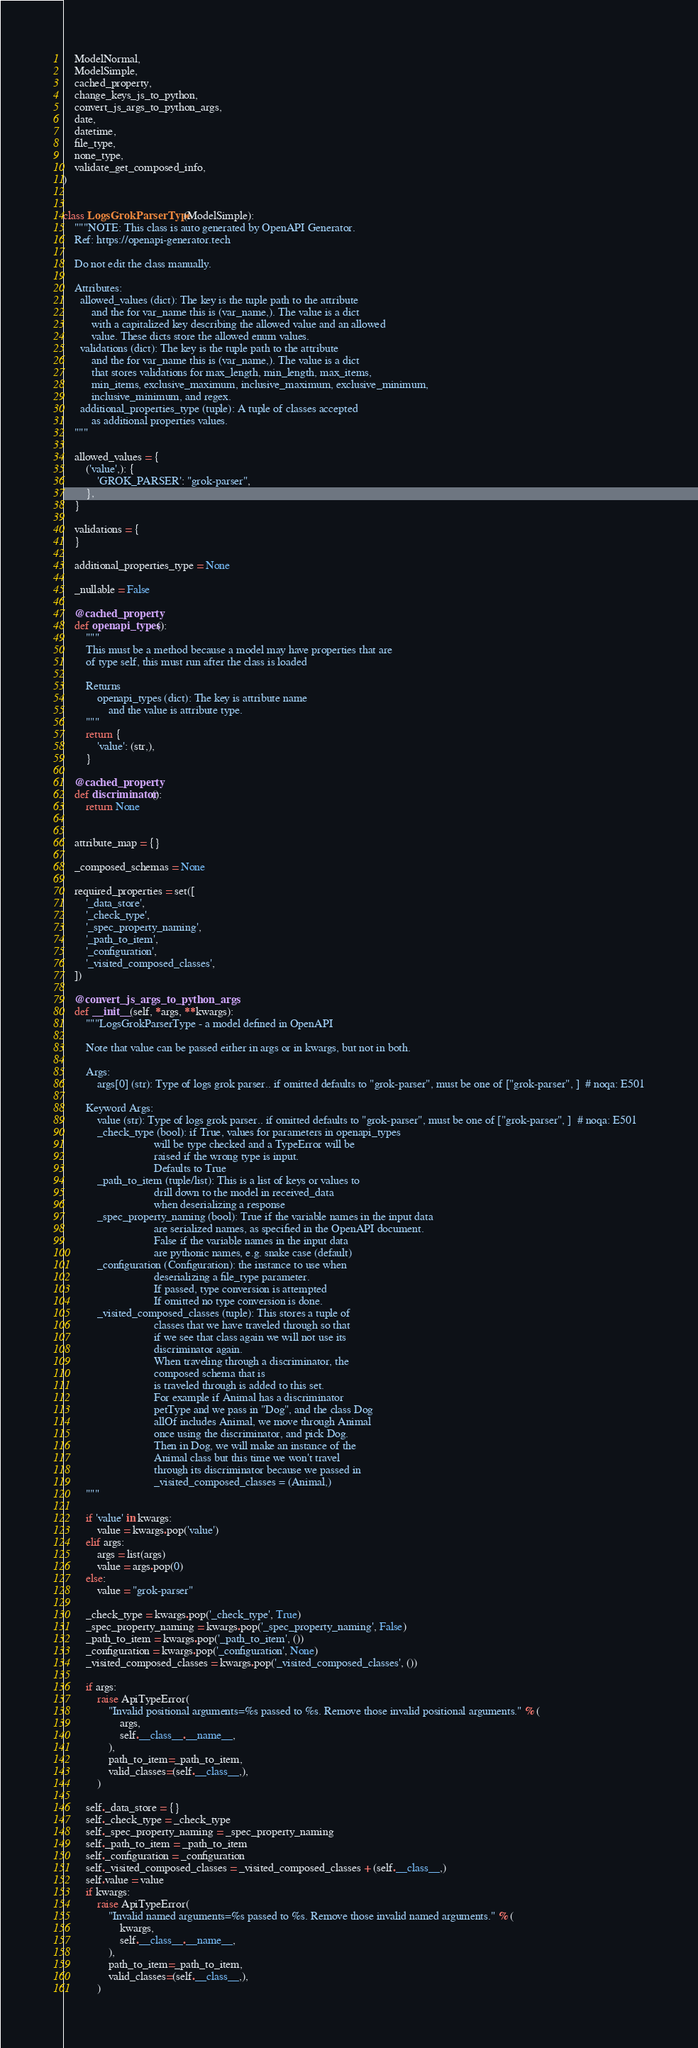Convert code to text. <code><loc_0><loc_0><loc_500><loc_500><_Python_>    ModelNormal,
    ModelSimple,
    cached_property,
    change_keys_js_to_python,
    convert_js_args_to_python_args,
    date,
    datetime,
    file_type,
    none_type,
    validate_get_composed_info,
)


class LogsGrokParserType(ModelSimple):
    """NOTE: This class is auto generated by OpenAPI Generator.
    Ref: https://openapi-generator.tech

    Do not edit the class manually.

    Attributes:
      allowed_values (dict): The key is the tuple path to the attribute
          and the for var_name this is (var_name,). The value is a dict
          with a capitalized key describing the allowed value and an allowed
          value. These dicts store the allowed enum values.
      validations (dict): The key is the tuple path to the attribute
          and the for var_name this is (var_name,). The value is a dict
          that stores validations for max_length, min_length, max_items,
          min_items, exclusive_maximum, inclusive_maximum, exclusive_minimum,
          inclusive_minimum, and regex.
      additional_properties_type (tuple): A tuple of classes accepted
          as additional properties values.
    """

    allowed_values = {
        ('value',): {
            'GROK_PARSER': "grok-parser",
        },
    }

    validations = {
    }

    additional_properties_type = None

    _nullable = False

    @cached_property
    def openapi_types():
        """
        This must be a method because a model may have properties that are
        of type self, this must run after the class is loaded

        Returns
            openapi_types (dict): The key is attribute name
                and the value is attribute type.
        """
        return {
            'value': (str,),
        }

    @cached_property
    def discriminator():
        return None


    attribute_map = {}

    _composed_schemas = None

    required_properties = set([
        '_data_store',
        '_check_type',
        '_spec_property_naming',
        '_path_to_item',
        '_configuration',
        '_visited_composed_classes',
    ])

    @convert_js_args_to_python_args
    def __init__(self, *args, **kwargs):
        """LogsGrokParserType - a model defined in OpenAPI

        Note that value can be passed either in args or in kwargs, but not in both.

        Args:
            args[0] (str): Type of logs grok parser.. if omitted defaults to "grok-parser", must be one of ["grok-parser", ]  # noqa: E501

        Keyword Args:
            value (str): Type of logs grok parser.. if omitted defaults to "grok-parser", must be one of ["grok-parser", ]  # noqa: E501
            _check_type (bool): if True, values for parameters in openapi_types
                                will be type checked and a TypeError will be
                                raised if the wrong type is input.
                                Defaults to True
            _path_to_item (tuple/list): This is a list of keys or values to
                                drill down to the model in received_data
                                when deserializing a response
            _spec_property_naming (bool): True if the variable names in the input data
                                are serialized names, as specified in the OpenAPI document.
                                False if the variable names in the input data
                                are pythonic names, e.g. snake case (default)
            _configuration (Configuration): the instance to use when
                                deserializing a file_type parameter.
                                If passed, type conversion is attempted
                                If omitted no type conversion is done.
            _visited_composed_classes (tuple): This stores a tuple of
                                classes that we have traveled through so that
                                if we see that class again we will not use its
                                discriminator again.
                                When traveling through a discriminator, the
                                composed schema that is
                                is traveled through is added to this set.
                                For example if Animal has a discriminator
                                petType and we pass in "Dog", and the class Dog
                                allOf includes Animal, we move through Animal
                                once using the discriminator, and pick Dog.
                                Then in Dog, we will make an instance of the
                                Animal class but this time we won't travel
                                through its discriminator because we passed in
                                _visited_composed_classes = (Animal,)
        """

        if 'value' in kwargs:
            value = kwargs.pop('value')
        elif args:
            args = list(args)
            value = args.pop(0)
        else:
            value = "grok-parser"

        _check_type = kwargs.pop('_check_type', True)
        _spec_property_naming = kwargs.pop('_spec_property_naming', False)
        _path_to_item = kwargs.pop('_path_to_item', ())
        _configuration = kwargs.pop('_configuration', None)
        _visited_composed_classes = kwargs.pop('_visited_composed_classes', ())

        if args:
            raise ApiTypeError(
                "Invalid positional arguments=%s passed to %s. Remove those invalid positional arguments." % (
                    args,
                    self.__class__.__name__,
                ),
                path_to_item=_path_to_item,
                valid_classes=(self.__class__,),
            )

        self._data_store = {}
        self._check_type = _check_type
        self._spec_property_naming = _spec_property_naming
        self._path_to_item = _path_to_item
        self._configuration = _configuration
        self._visited_composed_classes = _visited_composed_classes + (self.__class__,)
        self.value = value
        if kwargs:
            raise ApiTypeError(
                "Invalid named arguments=%s passed to %s. Remove those invalid named arguments." % (
                    kwargs,
                    self.__class__.__name__,
                ),
                path_to_item=_path_to_item,
                valid_classes=(self.__class__,),
            )
</code> 